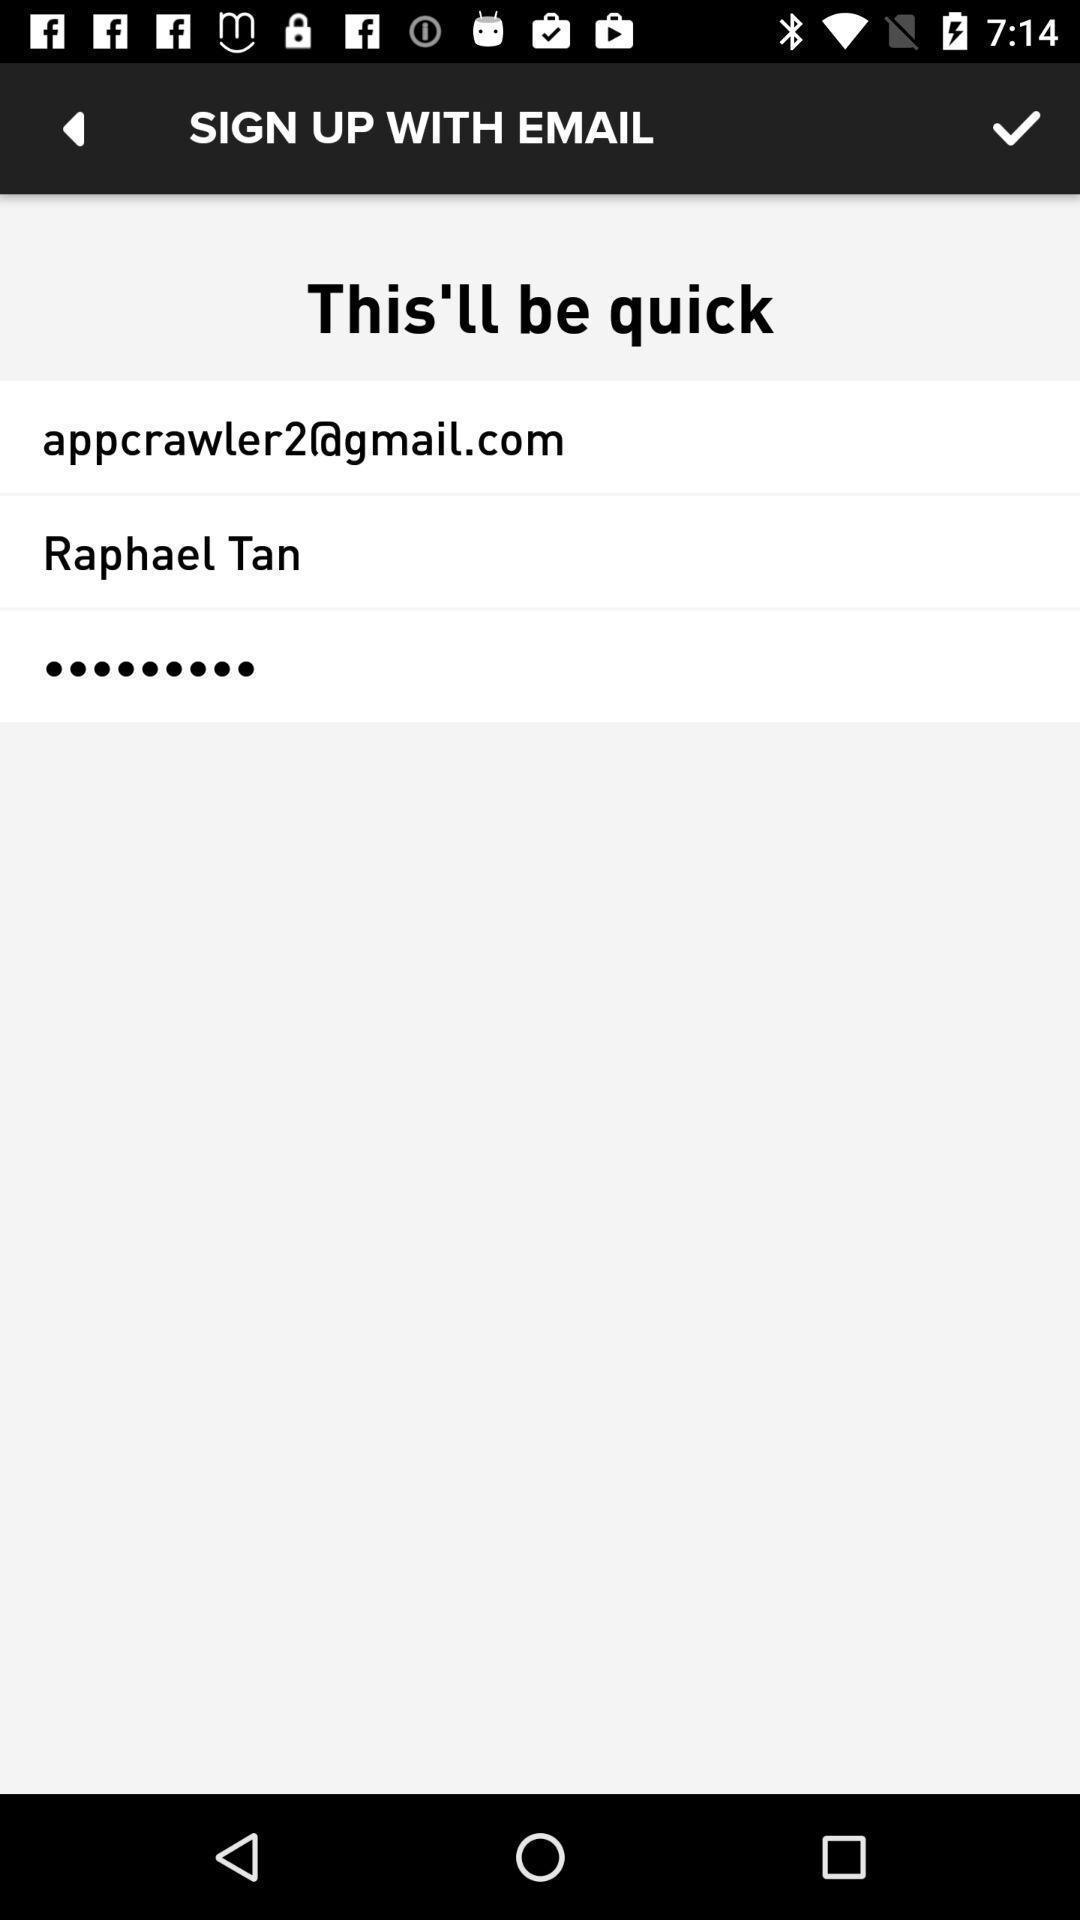Tell me what you see in this picture. Sign-in page. 